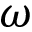<formula> <loc_0><loc_0><loc_500><loc_500>\omega</formula> 